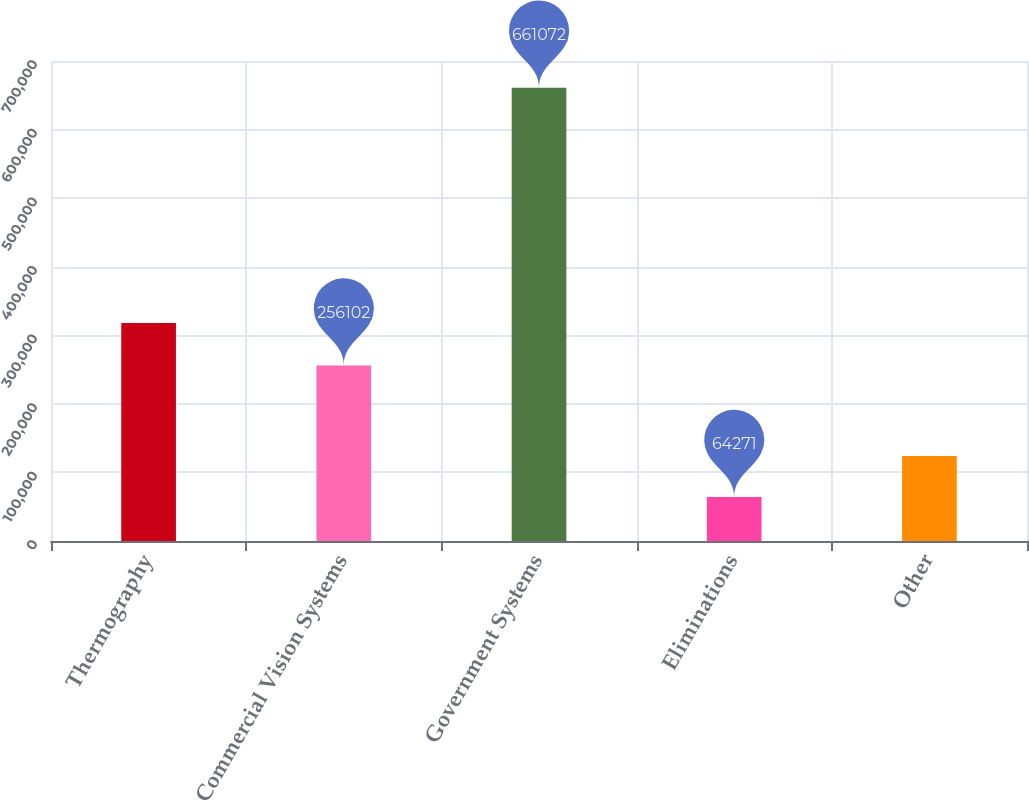Convert chart to OTSL. <chart><loc_0><loc_0><loc_500><loc_500><bar_chart><fcel>Thermography<fcel>Commercial Vision Systems<fcel>Government Systems<fcel>Eliminations<fcel>Other<nl><fcel>317936<fcel>256102<fcel>661072<fcel>64271<fcel>123951<nl></chart> 